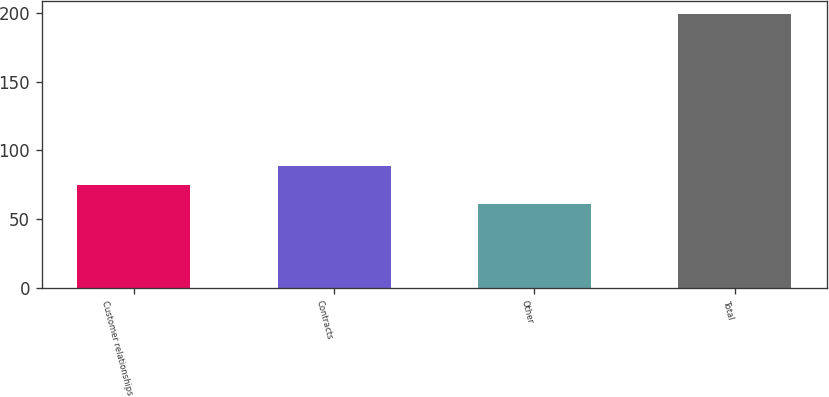Convert chart. <chart><loc_0><loc_0><loc_500><loc_500><bar_chart><fcel>Customer relationships<fcel>Contracts<fcel>Other<fcel>Total<nl><fcel>74.8<fcel>88.6<fcel>61<fcel>199<nl></chart> 